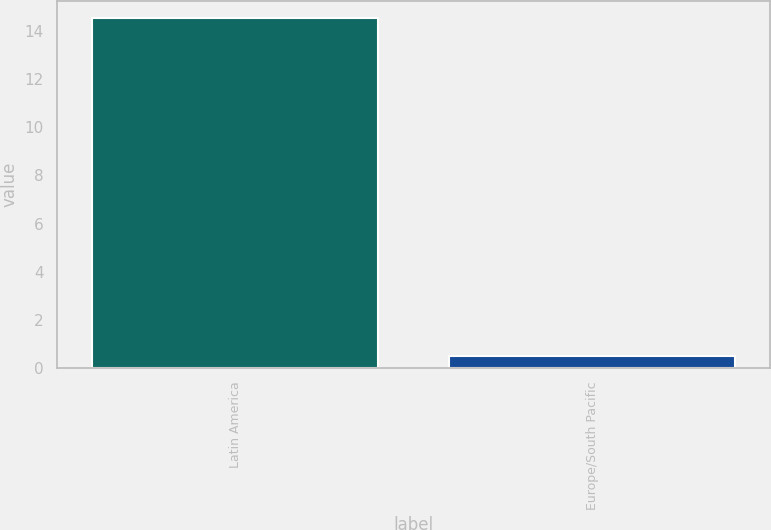Convert chart. <chart><loc_0><loc_0><loc_500><loc_500><bar_chart><fcel>Latin America<fcel>Europe/South Pacific<nl><fcel>14.5<fcel>0.5<nl></chart> 